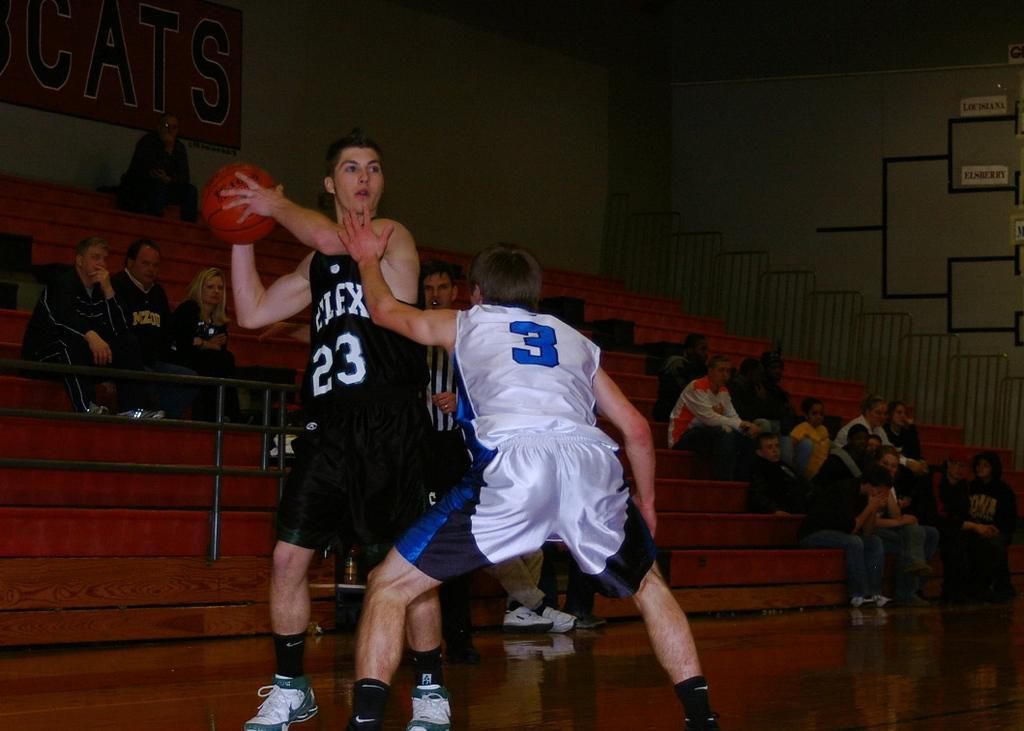How would you summarize this image in a sentence or two? In this image there are two players of different teams are playing the basketball. In the background there are few people sitting and watching the game. On the left side top there is a board attached to the wall. 